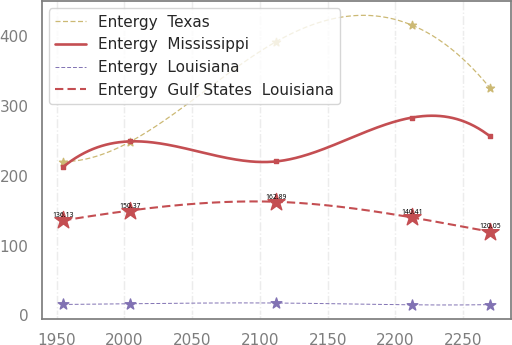<chart> <loc_0><loc_0><loc_500><loc_500><line_chart><ecel><fcel>Entergy  Texas<fcel>Entergy  Mississippi<fcel>Entergy  Louisiana<fcel>Entergy  Gulf States  Louisiana<nl><fcel>1954.79<fcel>220.49<fcel>212.63<fcel>15.76<fcel>136.13<nl><fcel>2004.41<fcel>249.01<fcel>249.41<fcel>16.77<fcel>150.37<nl><fcel>2111.57<fcel>391.84<fcel>220.61<fcel>17.83<fcel>162.89<nl><fcel>2212.16<fcel>415.97<fcel>283.49<fcel>15.24<fcel>140.41<nl><fcel>2269.71<fcel>325.99<fcel>256.73<fcel>15.5<fcel>120.05<nl></chart> 